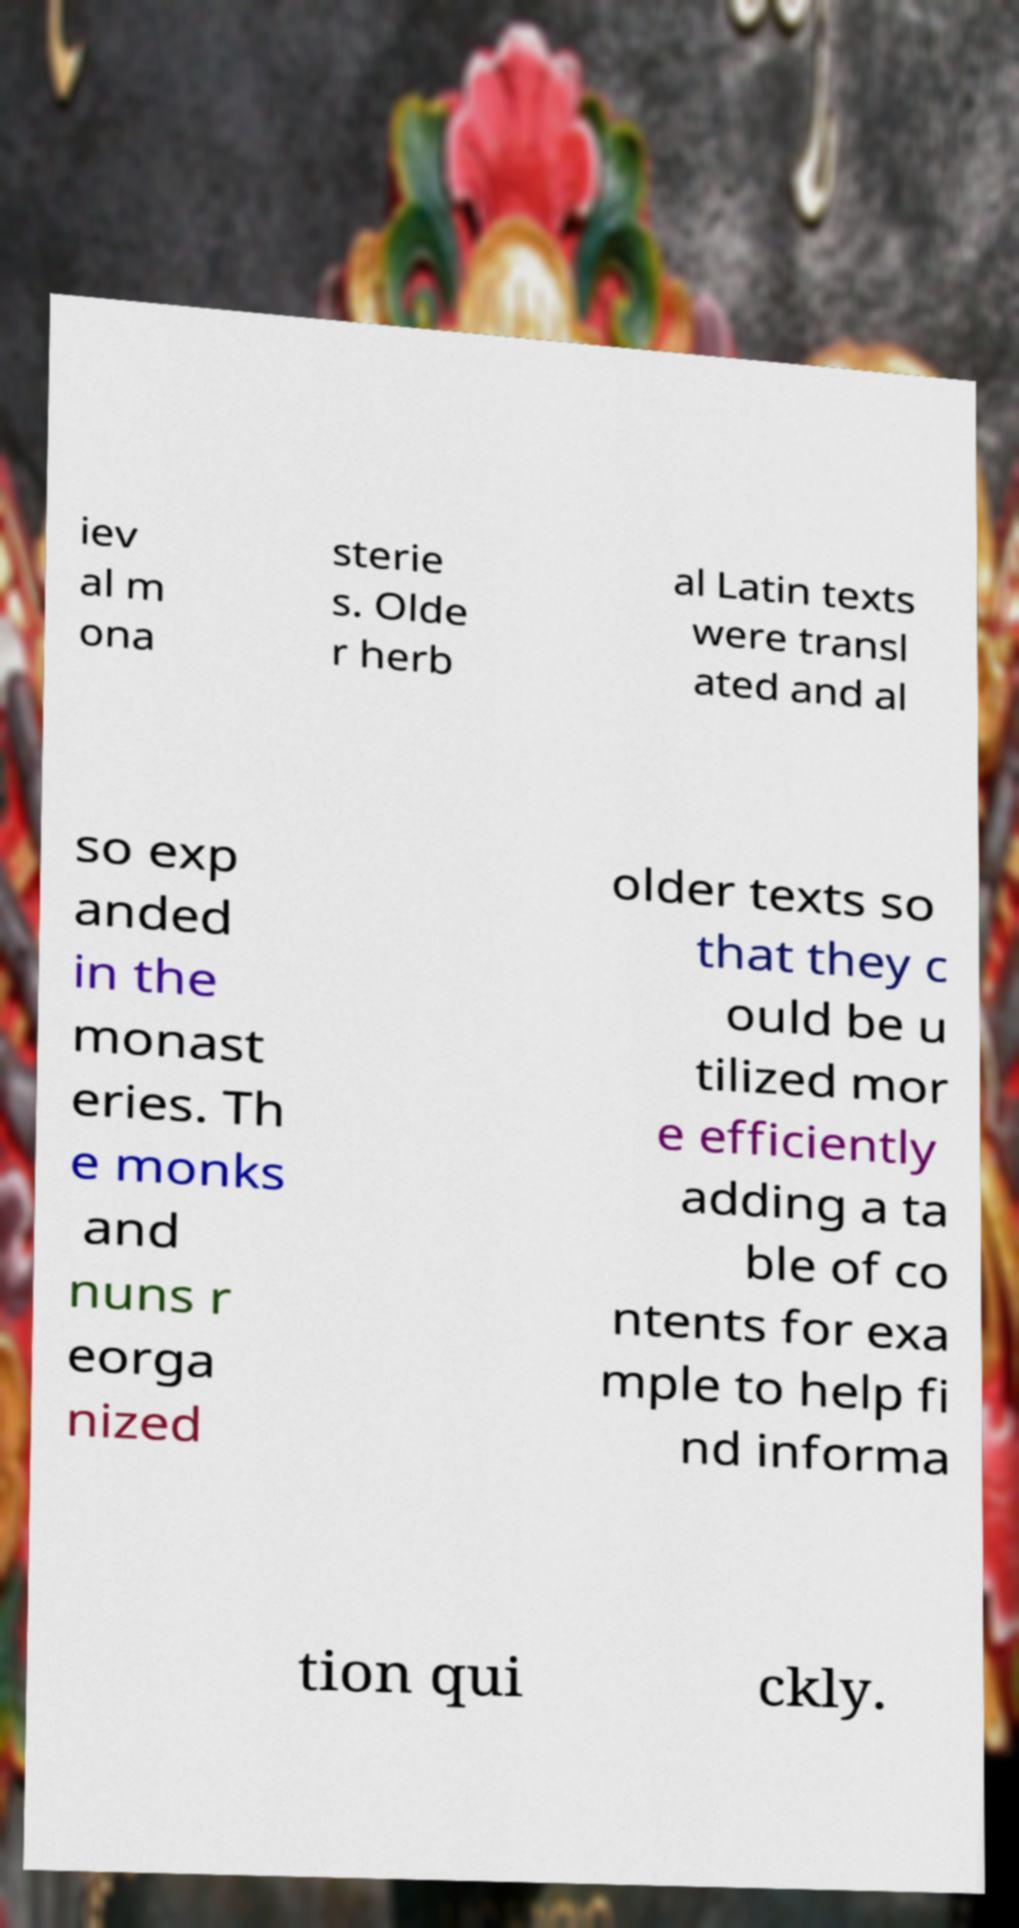For documentation purposes, I need the text within this image transcribed. Could you provide that? iev al m ona sterie s. Olde r herb al Latin texts were transl ated and al so exp anded in the monast eries. Th e monks and nuns r eorga nized older texts so that they c ould be u tilized mor e efficiently adding a ta ble of co ntents for exa mple to help fi nd informa tion qui ckly. 